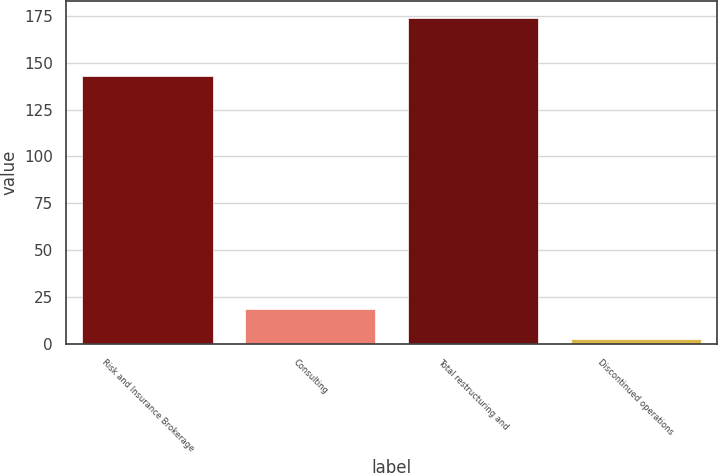<chart> <loc_0><loc_0><loc_500><loc_500><bar_chart><fcel>Risk and Insurance Brokerage<fcel>Consulting<fcel>Total restructuring and<fcel>Discontinued operations<nl><fcel>143<fcel>18.5<fcel>174<fcel>3<nl></chart> 